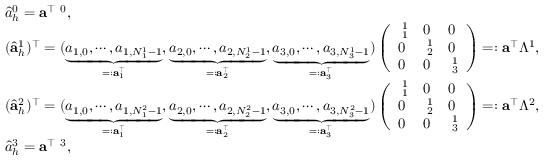Convert formula to latex. <formula><loc_0><loc_0><loc_500><loc_500>\begin{array} { r l } & { \hat { a } _ { h } ^ { 0 } = { \mathbf a } ^ { \top } { \mathbf \Lambda } ^ { 0 } , } \\ & { ( \hat { \mathbf a } _ { h } ^ { 1 } ) ^ { \top } = ( \underbrace { a _ { 1 , 0 } , \cdots , a _ { 1 , N _ { 1 } ^ { 1 } - 1 } } _ { = \colon { \mathbf a } _ { 1 } ^ { \top } } , \underbrace { a _ { 2 , 0 } , \cdots , a _ { 2 , N _ { 2 } ^ { 1 } - 1 } } _ { = \colon { \mathbf a } _ { 2 } ^ { \top } } , \underbrace { a _ { 3 , 0 } , \cdots , a _ { 3 , N _ { 3 } ^ { 1 } - 1 } } _ { = \colon { \mathbf a } _ { 3 } ^ { \top } } ) \left ( \begin{array} { l l l } { { \mathbf \Lambda } _ { 1 } ^ { 1 } } & { 0 } & { 0 } \\ { 0 } & { { \mathbf \Lambda } _ { 2 } ^ { 1 } } & { 0 } \\ { 0 } & { 0 } & { { \mathbf \Lambda } _ { 3 } ^ { 1 } } \end{array} \right ) = \colon { \mathbf a } ^ { \top } \mathbb { \Lambda } ^ { 1 } , } \\ & { ( \hat { \mathbf a } _ { h } ^ { 2 } ) ^ { \top } = ( \underbrace { a _ { 1 , 0 } , \cdots , a _ { 1 , N _ { 1 } ^ { 2 } - 1 } } _ { = \colon { \mathbf a } _ { 1 } ^ { \top } } , \underbrace { a _ { 2 , 0 } , \cdots , a _ { 2 , N _ { 2 } ^ { 2 } - 1 } } _ { = \colon { \mathbf a } _ { 2 } ^ { \top } } , \underbrace { a _ { 3 , 0 } , \cdots , a _ { 3 , N _ { 3 } ^ { 2 } - 1 } } _ { = \colon { \mathbf a } _ { 3 } ^ { \top } } ) \left ( \begin{array} { l l l } { { \mathbf \Lambda } _ { 1 } ^ { 1 } } & { 0 } & { 0 } \\ { 0 } & { { \mathbf \Lambda } _ { 2 } ^ { 1 } } & { 0 } \\ { 0 } & { 0 } & { { \mathbf \Lambda } _ { 3 } ^ { 1 } } \end{array} \right ) = \colon { \mathbf a } ^ { \top } \mathbb { \Lambda } ^ { 2 } , } \\ & { \hat { a } _ { h } ^ { 3 } = { \mathbf a } ^ { \top } { \mathbf \Lambda } ^ { 3 } , } \end{array}</formula> 